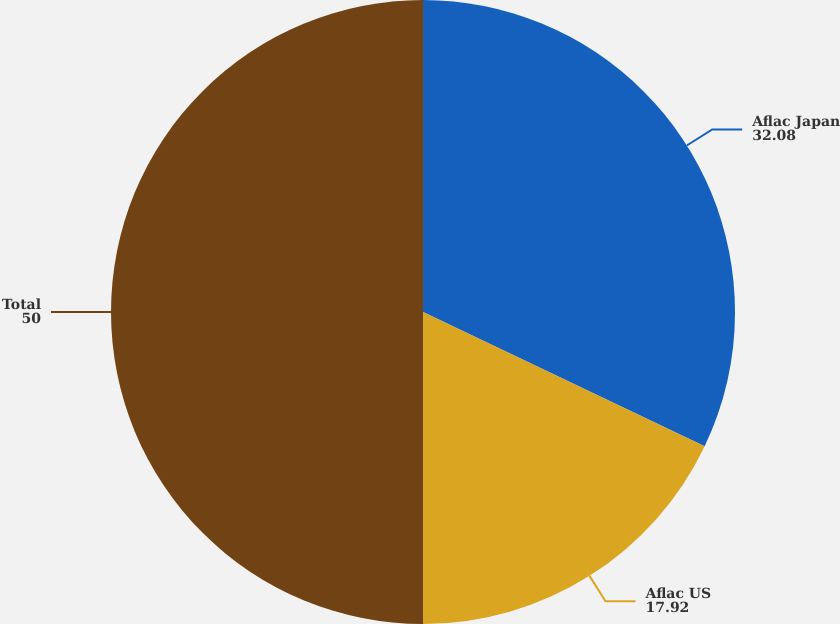Convert chart. <chart><loc_0><loc_0><loc_500><loc_500><pie_chart><fcel>Aflac Japan<fcel>Aflac US<fcel>Total<nl><fcel>32.08%<fcel>17.92%<fcel>50.0%<nl></chart> 